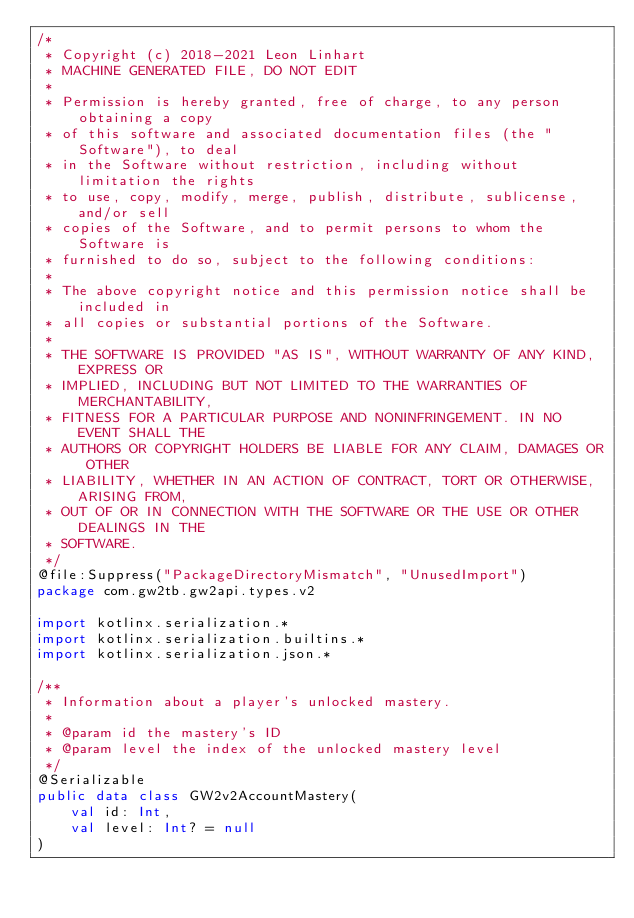Convert code to text. <code><loc_0><loc_0><loc_500><loc_500><_Kotlin_>/*
 * Copyright (c) 2018-2021 Leon Linhart
 * MACHINE GENERATED FILE, DO NOT EDIT
 *
 * Permission is hereby granted, free of charge, to any person obtaining a copy
 * of this software and associated documentation files (the "Software"), to deal
 * in the Software without restriction, including without limitation the rights
 * to use, copy, modify, merge, publish, distribute, sublicense, and/or sell
 * copies of the Software, and to permit persons to whom the Software is
 * furnished to do so, subject to the following conditions:
 *
 * The above copyright notice and this permission notice shall be included in
 * all copies or substantial portions of the Software.
 *
 * THE SOFTWARE IS PROVIDED "AS IS", WITHOUT WARRANTY OF ANY KIND, EXPRESS OR
 * IMPLIED, INCLUDING BUT NOT LIMITED TO THE WARRANTIES OF MERCHANTABILITY,
 * FITNESS FOR A PARTICULAR PURPOSE AND NONINFRINGEMENT. IN NO EVENT SHALL THE
 * AUTHORS OR COPYRIGHT HOLDERS BE LIABLE FOR ANY CLAIM, DAMAGES OR OTHER
 * LIABILITY, WHETHER IN AN ACTION OF CONTRACT, TORT OR OTHERWISE, ARISING FROM,
 * OUT OF OR IN CONNECTION WITH THE SOFTWARE OR THE USE OR OTHER DEALINGS IN THE
 * SOFTWARE.
 */
@file:Suppress("PackageDirectoryMismatch", "UnusedImport")
package com.gw2tb.gw2api.types.v2

import kotlinx.serialization.*
import kotlinx.serialization.builtins.*
import kotlinx.serialization.json.*

/**
 * Information about a player's unlocked mastery.
 *
 * @param id the mastery's ID
 * @param level the index of the unlocked mastery level
 */
@Serializable
public data class GW2v2AccountMastery(
    val id: Int,
    val level: Int? = null
)</code> 